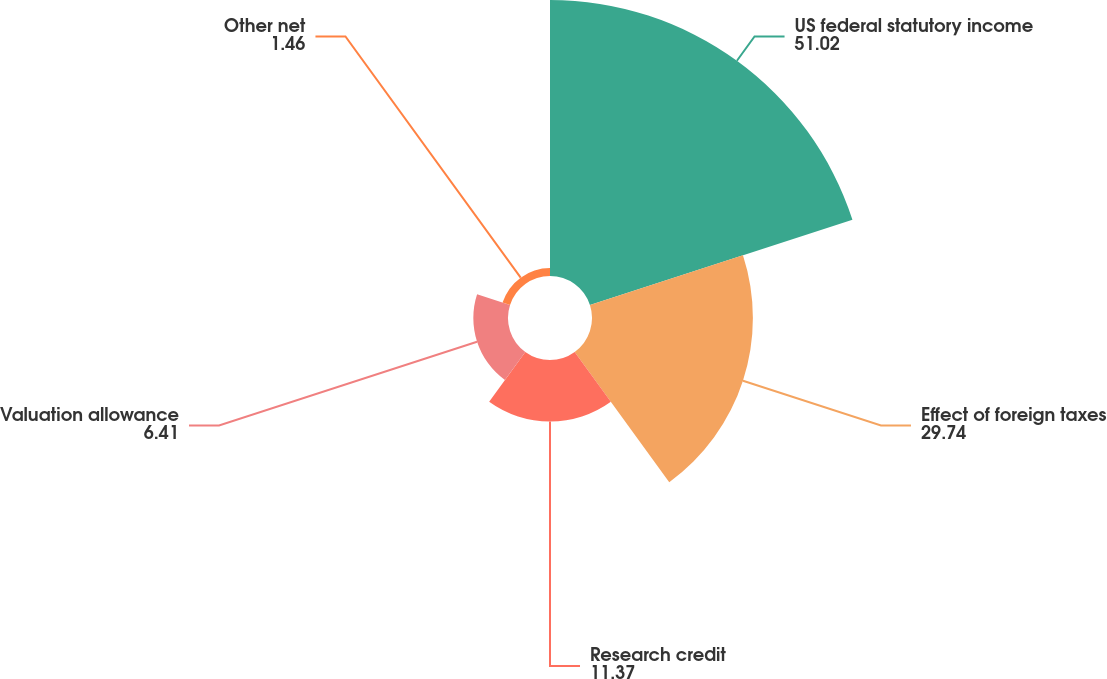Convert chart to OTSL. <chart><loc_0><loc_0><loc_500><loc_500><pie_chart><fcel>US federal statutory income<fcel>Effect of foreign taxes<fcel>Research credit<fcel>Valuation allowance<fcel>Other net<nl><fcel>51.02%<fcel>29.74%<fcel>11.37%<fcel>6.41%<fcel>1.46%<nl></chart> 